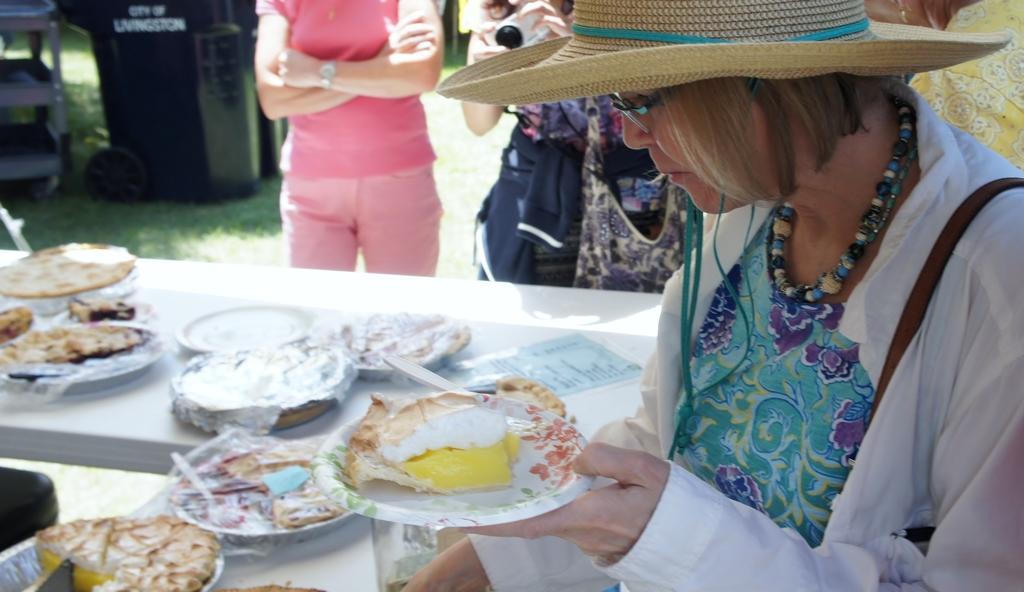How would you summarize this image in a sentence or two? In this image I can see the person sitting and holding the plate and I can see the food in the plate. In the background I can see few food items on the table and I can see group of people standing. 